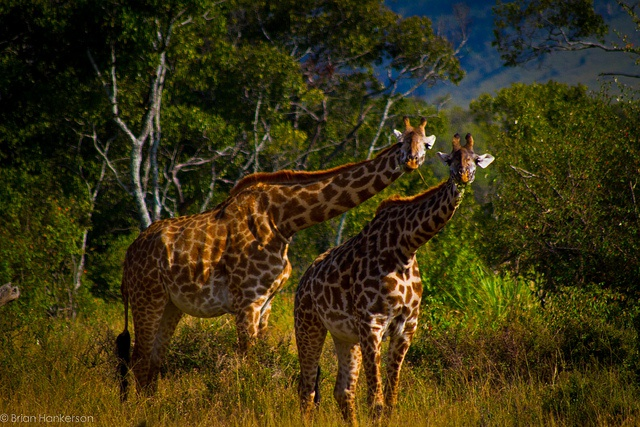Describe the objects in this image and their specific colors. I can see giraffe in black, maroon, and brown tones and giraffe in black, maroon, and olive tones in this image. 